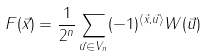<formula> <loc_0><loc_0><loc_500><loc_500>F ( \vec { x } ) = \frac { 1 } { 2 ^ { n } } \sum _ { \vec { u } \in V _ { n } } ( - 1 ) ^ { \langle \vec { x } , \vec { u } \rangle } W ( \vec { u } )</formula> 